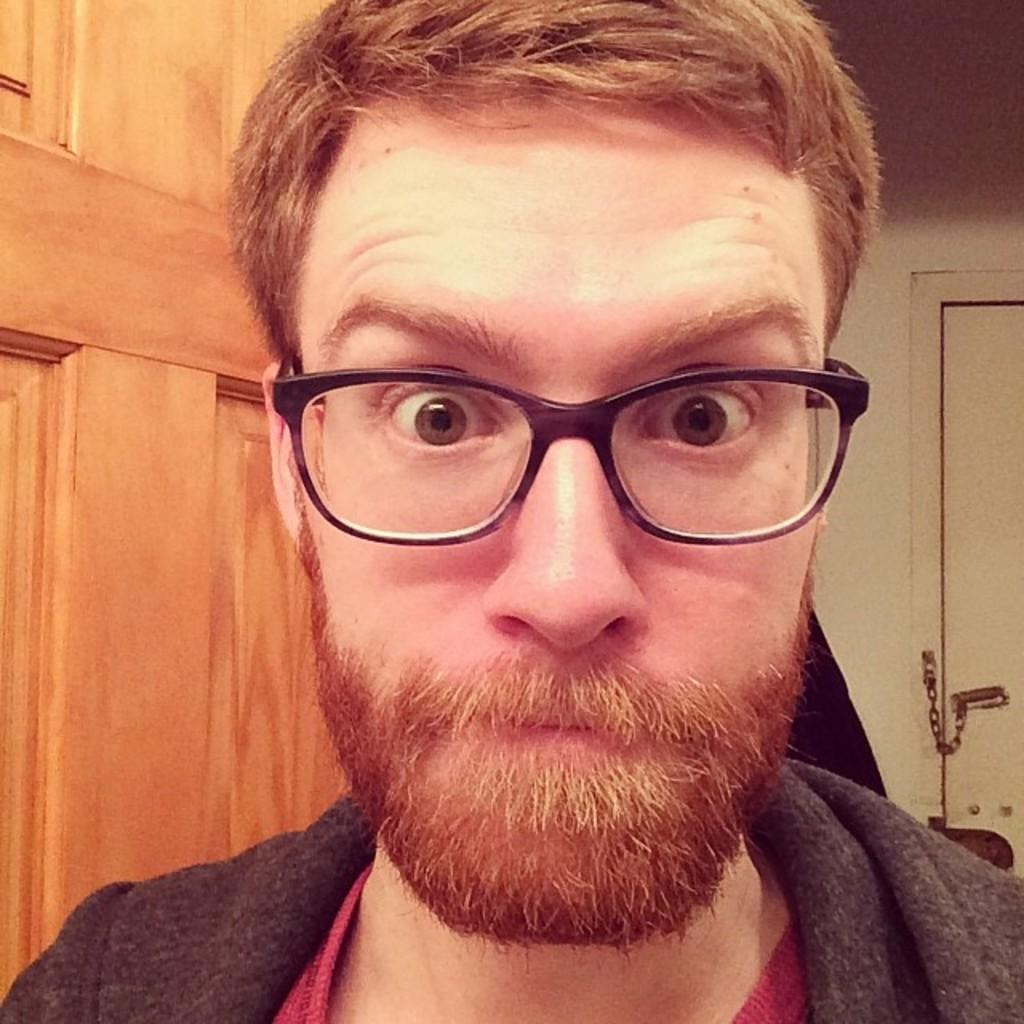What is present in the image? There is a person in the image. Can you describe the person's appearance? The person is wearing clothes and glasses. What is a feature of the setting in the image? There is a door in the image. What caused the plane to crash in the image? There is no plane present in the image, so it is not possible to determine the cause of a crash. 